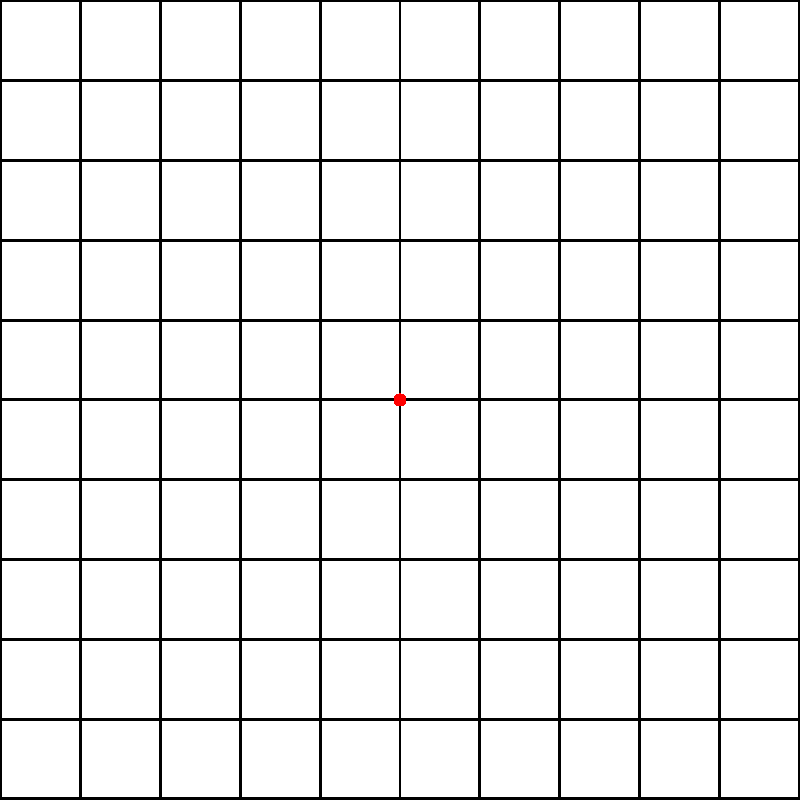In a spatial memory task, participants are shown a 5x5 grid with four objects (A, B, C, and D) placed in specific locations. After a brief exposure, the grid is cleared, and participants must recall the objects' positions. Given the grid above, what is the total Manhattan distance between all adjacent pairs of objects when following the dashed line path? To solve this problem, we need to follow these steps:

1. Understand Manhattan distance: It's the sum of the absolute differences of the coordinates.

2. Identify the coordinates of each object:
   A: (1,5)
   B: (3,4)
   C: (5,3)
   D: (2,1)

3. Calculate the Manhattan distance between adjacent pairs:

   A to B: |1-3| + |5-4| = 2 + 1 = 3
   B to C: |3-5| + |4-3| = 2 + 1 = 3
   C to D: |5-2| + |3-1| = 3 + 2 = 5

4. Sum up all the distances:
   Total distance = 3 + 3 + 5 = 11

Therefore, the total Manhattan distance between all adjacent pairs of objects when following the dashed line path is 11 units.
Answer: 11 units 